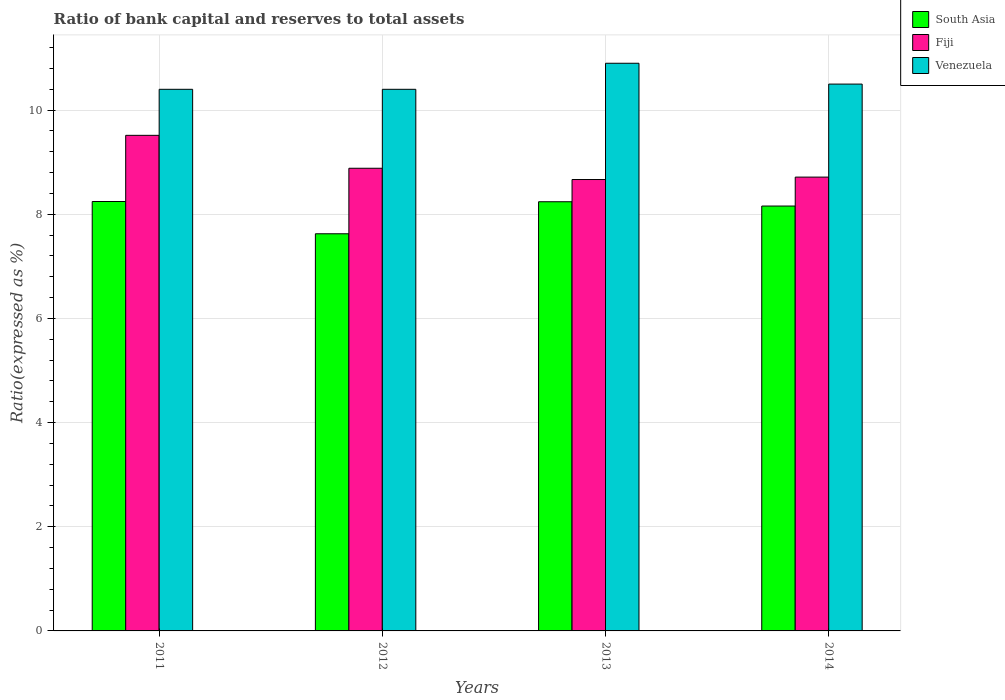How many different coloured bars are there?
Your response must be concise. 3. Are the number of bars per tick equal to the number of legend labels?
Provide a succinct answer. Yes. Are the number of bars on each tick of the X-axis equal?
Ensure brevity in your answer.  Yes. How many bars are there on the 2nd tick from the left?
Your answer should be compact. 3. In how many cases, is the number of bars for a given year not equal to the number of legend labels?
Your response must be concise. 0. Across all years, what is the maximum ratio of bank capital and reserves to total assets in South Asia?
Provide a short and direct response. 8.25. Across all years, what is the minimum ratio of bank capital and reserves to total assets in Fiji?
Provide a succinct answer. 8.67. What is the total ratio of bank capital and reserves to total assets in South Asia in the graph?
Give a very brief answer. 32.27. What is the difference between the ratio of bank capital and reserves to total assets in Fiji in 2011 and that in 2012?
Your response must be concise. 0.63. What is the difference between the ratio of bank capital and reserves to total assets in South Asia in 2011 and the ratio of bank capital and reserves to total assets in Venezuela in 2013?
Offer a terse response. -2.65. What is the average ratio of bank capital and reserves to total assets in Fiji per year?
Make the answer very short. 8.95. In the year 2011, what is the difference between the ratio of bank capital and reserves to total assets in South Asia and ratio of bank capital and reserves to total assets in Venezuela?
Offer a terse response. -2.15. In how many years, is the ratio of bank capital and reserves to total assets in Fiji greater than 6 %?
Keep it short and to the point. 4. What is the ratio of the ratio of bank capital and reserves to total assets in South Asia in 2012 to that in 2013?
Offer a very short reply. 0.93. What is the difference between the highest and the second highest ratio of bank capital and reserves to total assets in Venezuela?
Your answer should be very brief. 0.4. What is the difference between the highest and the lowest ratio of bank capital and reserves to total assets in Fiji?
Your answer should be compact. 0.85. In how many years, is the ratio of bank capital and reserves to total assets in South Asia greater than the average ratio of bank capital and reserves to total assets in South Asia taken over all years?
Your answer should be very brief. 3. Is the sum of the ratio of bank capital and reserves to total assets in Venezuela in 2011 and 2014 greater than the maximum ratio of bank capital and reserves to total assets in South Asia across all years?
Offer a terse response. Yes. What does the 3rd bar from the left in 2012 represents?
Your answer should be compact. Venezuela. What does the 1st bar from the right in 2014 represents?
Make the answer very short. Venezuela. How many bars are there?
Your answer should be compact. 12. Are all the bars in the graph horizontal?
Your answer should be compact. No. How many years are there in the graph?
Provide a short and direct response. 4. What is the difference between two consecutive major ticks on the Y-axis?
Your answer should be very brief. 2. Are the values on the major ticks of Y-axis written in scientific E-notation?
Make the answer very short. No. Does the graph contain any zero values?
Ensure brevity in your answer.  No. How many legend labels are there?
Your answer should be very brief. 3. How are the legend labels stacked?
Provide a short and direct response. Vertical. What is the title of the graph?
Make the answer very short. Ratio of bank capital and reserves to total assets. Does "Upper middle income" appear as one of the legend labels in the graph?
Keep it short and to the point. No. What is the label or title of the Y-axis?
Your response must be concise. Ratio(expressed as %). What is the Ratio(expressed as %) in South Asia in 2011?
Your answer should be compact. 8.25. What is the Ratio(expressed as %) of Fiji in 2011?
Your answer should be very brief. 9.52. What is the Ratio(expressed as %) of Venezuela in 2011?
Provide a short and direct response. 10.4. What is the Ratio(expressed as %) of South Asia in 2012?
Your response must be concise. 7.63. What is the Ratio(expressed as %) in Fiji in 2012?
Provide a succinct answer. 8.88. What is the Ratio(expressed as %) in South Asia in 2013?
Keep it short and to the point. 8.24. What is the Ratio(expressed as %) of Fiji in 2013?
Provide a succinct answer. 8.67. What is the Ratio(expressed as %) in South Asia in 2014?
Make the answer very short. 8.16. What is the Ratio(expressed as %) in Fiji in 2014?
Your response must be concise. 8.71. Across all years, what is the maximum Ratio(expressed as %) of South Asia?
Your answer should be very brief. 8.25. Across all years, what is the maximum Ratio(expressed as %) of Fiji?
Give a very brief answer. 9.52. Across all years, what is the maximum Ratio(expressed as %) of Venezuela?
Provide a succinct answer. 10.9. Across all years, what is the minimum Ratio(expressed as %) of South Asia?
Make the answer very short. 7.63. Across all years, what is the minimum Ratio(expressed as %) in Fiji?
Offer a terse response. 8.67. Across all years, what is the minimum Ratio(expressed as %) in Venezuela?
Your answer should be compact. 10.4. What is the total Ratio(expressed as %) in South Asia in the graph?
Offer a very short reply. 32.27. What is the total Ratio(expressed as %) of Fiji in the graph?
Give a very brief answer. 35.78. What is the total Ratio(expressed as %) of Venezuela in the graph?
Your answer should be very brief. 42.2. What is the difference between the Ratio(expressed as %) of South Asia in 2011 and that in 2012?
Offer a very short reply. 0.62. What is the difference between the Ratio(expressed as %) of Fiji in 2011 and that in 2012?
Provide a short and direct response. 0.63. What is the difference between the Ratio(expressed as %) of Venezuela in 2011 and that in 2012?
Give a very brief answer. 0. What is the difference between the Ratio(expressed as %) of South Asia in 2011 and that in 2013?
Your answer should be compact. 0. What is the difference between the Ratio(expressed as %) in Fiji in 2011 and that in 2013?
Make the answer very short. 0.85. What is the difference between the Ratio(expressed as %) in South Asia in 2011 and that in 2014?
Offer a very short reply. 0.09. What is the difference between the Ratio(expressed as %) in Fiji in 2011 and that in 2014?
Make the answer very short. 0.8. What is the difference between the Ratio(expressed as %) in Venezuela in 2011 and that in 2014?
Your answer should be compact. -0.1. What is the difference between the Ratio(expressed as %) in South Asia in 2012 and that in 2013?
Your answer should be compact. -0.61. What is the difference between the Ratio(expressed as %) in Fiji in 2012 and that in 2013?
Make the answer very short. 0.22. What is the difference between the Ratio(expressed as %) in South Asia in 2012 and that in 2014?
Ensure brevity in your answer.  -0.53. What is the difference between the Ratio(expressed as %) in Fiji in 2012 and that in 2014?
Offer a very short reply. 0.17. What is the difference between the Ratio(expressed as %) of South Asia in 2013 and that in 2014?
Give a very brief answer. 0.08. What is the difference between the Ratio(expressed as %) of Fiji in 2013 and that in 2014?
Provide a short and direct response. -0.05. What is the difference between the Ratio(expressed as %) in South Asia in 2011 and the Ratio(expressed as %) in Fiji in 2012?
Your response must be concise. -0.64. What is the difference between the Ratio(expressed as %) of South Asia in 2011 and the Ratio(expressed as %) of Venezuela in 2012?
Offer a terse response. -2.15. What is the difference between the Ratio(expressed as %) of Fiji in 2011 and the Ratio(expressed as %) of Venezuela in 2012?
Provide a succinct answer. -0.88. What is the difference between the Ratio(expressed as %) of South Asia in 2011 and the Ratio(expressed as %) of Fiji in 2013?
Offer a terse response. -0.42. What is the difference between the Ratio(expressed as %) in South Asia in 2011 and the Ratio(expressed as %) in Venezuela in 2013?
Your answer should be compact. -2.65. What is the difference between the Ratio(expressed as %) of Fiji in 2011 and the Ratio(expressed as %) of Venezuela in 2013?
Offer a very short reply. -1.38. What is the difference between the Ratio(expressed as %) in South Asia in 2011 and the Ratio(expressed as %) in Fiji in 2014?
Ensure brevity in your answer.  -0.47. What is the difference between the Ratio(expressed as %) in South Asia in 2011 and the Ratio(expressed as %) in Venezuela in 2014?
Provide a succinct answer. -2.25. What is the difference between the Ratio(expressed as %) in Fiji in 2011 and the Ratio(expressed as %) in Venezuela in 2014?
Offer a terse response. -0.98. What is the difference between the Ratio(expressed as %) of South Asia in 2012 and the Ratio(expressed as %) of Fiji in 2013?
Your response must be concise. -1.04. What is the difference between the Ratio(expressed as %) in South Asia in 2012 and the Ratio(expressed as %) in Venezuela in 2013?
Your response must be concise. -3.27. What is the difference between the Ratio(expressed as %) of Fiji in 2012 and the Ratio(expressed as %) of Venezuela in 2013?
Make the answer very short. -2.02. What is the difference between the Ratio(expressed as %) of South Asia in 2012 and the Ratio(expressed as %) of Fiji in 2014?
Provide a succinct answer. -1.09. What is the difference between the Ratio(expressed as %) in South Asia in 2012 and the Ratio(expressed as %) in Venezuela in 2014?
Your answer should be compact. -2.87. What is the difference between the Ratio(expressed as %) of Fiji in 2012 and the Ratio(expressed as %) of Venezuela in 2014?
Your response must be concise. -1.62. What is the difference between the Ratio(expressed as %) of South Asia in 2013 and the Ratio(expressed as %) of Fiji in 2014?
Your answer should be compact. -0.47. What is the difference between the Ratio(expressed as %) of South Asia in 2013 and the Ratio(expressed as %) of Venezuela in 2014?
Your response must be concise. -2.26. What is the difference between the Ratio(expressed as %) in Fiji in 2013 and the Ratio(expressed as %) in Venezuela in 2014?
Your response must be concise. -1.83. What is the average Ratio(expressed as %) of South Asia per year?
Give a very brief answer. 8.07. What is the average Ratio(expressed as %) in Fiji per year?
Offer a very short reply. 8.95. What is the average Ratio(expressed as %) in Venezuela per year?
Provide a short and direct response. 10.55. In the year 2011, what is the difference between the Ratio(expressed as %) of South Asia and Ratio(expressed as %) of Fiji?
Provide a short and direct response. -1.27. In the year 2011, what is the difference between the Ratio(expressed as %) of South Asia and Ratio(expressed as %) of Venezuela?
Your answer should be very brief. -2.15. In the year 2011, what is the difference between the Ratio(expressed as %) of Fiji and Ratio(expressed as %) of Venezuela?
Give a very brief answer. -0.88. In the year 2012, what is the difference between the Ratio(expressed as %) in South Asia and Ratio(expressed as %) in Fiji?
Ensure brevity in your answer.  -1.26. In the year 2012, what is the difference between the Ratio(expressed as %) of South Asia and Ratio(expressed as %) of Venezuela?
Offer a very short reply. -2.77. In the year 2012, what is the difference between the Ratio(expressed as %) of Fiji and Ratio(expressed as %) of Venezuela?
Provide a short and direct response. -1.52. In the year 2013, what is the difference between the Ratio(expressed as %) in South Asia and Ratio(expressed as %) in Fiji?
Make the answer very short. -0.43. In the year 2013, what is the difference between the Ratio(expressed as %) in South Asia and Ratio(expressed as %) in Venezuela?
Provide a succinct answer. -2.66. In the year 2013, what is the difference between the Ratio(expressed as %) of Fiji and Ratio(expressed as %) of Venezuela?
Your response must be concise. -2.23. In the year 2014, what is the difference between the Ratio(expressed as %) of South Asia and Ratio(expressed as %) of Fiji?
Keep it short and to the point. -0.56. In the year 2014, what is the difference between the Ratio(expressed as %) of South Asia and Ratio(expressed as %) of Venezuela?
Your answer should be very brief. -2.34. In the year 2014, what is the difference between the Ratio(expressed as %) of Fiji and Ratio(expressed as %) of Venezuela?
Your answer should be compact. -1.79. What is the ratio of the Ratio(expressed as %) in South Asia in 2011 to that in 2012?
Offer a very short reply. 1.08. What is the ratio of the Ratio(expressed as %) of Fiji in 2011 to that in 2012?
Provide a short and direct response. 1.07. What is the ratio of the Ratio(expressed as %) in Venezuela in 2011 to that in 2012?
Provide a short and direct response. 1. What is the ratio of the Ratio(expressed as %) in South Asia in 2011 to that in 2013?
Keep it short and to the point. 1. What is the ratio of the Ratio(expressed as %) of Fiji in 2011 to that in 2013?
Provide a short and direct response. 1.1. What is the ratio of the Ratio(expressed as %) of Venezuela in 2011 to that in 2013?
Provide a succinct answer. 0.95. What is the ratio of the Ratio(expressed as %) of South Asia in 2011 to that in 2014?
Offer a terse response. 1.01. What is the ratio of the Ratio(expressed as %) in Fiji in 2011 to that in 2014?
Offer a very short reply. 1.09. What is the ratio of the Ratio(expressed as %) of Venezuela in 2011 to that in 2014?
Provide a succinct answer. 0.99. What is the ratio of the Ratio(expressed as %) of South Asia in 2012 to that in 2013?
Ensure brevity in your answer.  0.93. What is the ratio of the Ratio(expressed as %) in Venezuela in 2012 to that in 2013?
Offer a terse response. 0.95. What is the ratio of the Ratio(expressed as %) of South Asia in 2012 to that in 2014?
Offer a terse response. 0.93. What is the ratio of the Ratio(expressed as %) of Fiji in 2012 to that in 2014?
Keep it short and to the point. 1.02. What is the ratio of the Ratio(expressed as %) of South Asia in 2013 to that in 2014?
Provide a succinct answer. 1.01. What is the ratio of the Ratio(expressed as %) in Fiji in 2013 to that in 2014?
Make the answer very short. 0.99. What is the ratio of the Ratio(expressed as %) in Venezuela in 2013 to that in 2014?
Give a very brief answer. 1.04. What is the difference between the highest and the second highest Ratio(expressed as %) of South Asia?
Provide a short and direct response. 0. What is the difference between the highest and the second highest Ratio(expressed as %) of Fiji?
Keep it short and to the point. 0.63. What is the difference between the highest and the second highest Ratio(expressed as %) of Venezuela?
Offer a terse response. 0.4. What is the difference between the highest and the lowest Ratio(expressed as %) of South Asia?
Provide a succinct answer. 0.62. What is the difference between the highest and the lowest Ratio(expressed as %) of Fiji?
Ensure brevity in your answer.  0.85. 